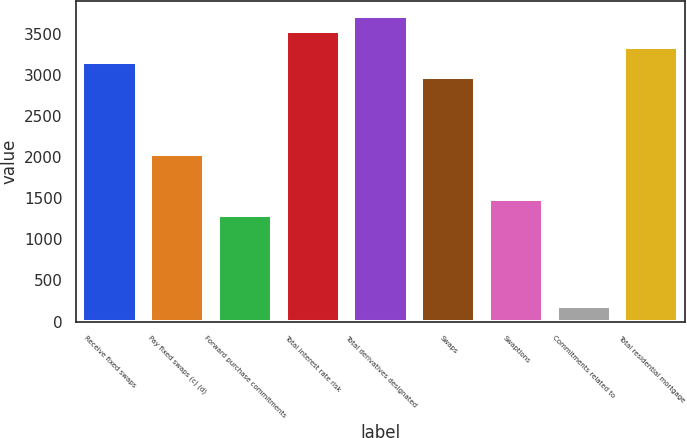Convert chart. <chart><loc_0><loc_0><loc_500><loc_500><bar_chart><fcel>Receive fixed swaps<fcel>Pay fixed swaps (c) (d)<fcel>Forward purchase commitments<fcel>Total interest rate risk<fcel>Total derivatives designated<fcel>Swaps<fcel>Swaptions<fcel>Commitments related to<fcel>Total residential mortgage<nl><fcel>3156.2<fcel>2042.6<fcel>1300.2<fcel>3527.4<fcel>3713<fcel>2970.6<fcel>1485.8<fcel>186.6<fcel>3341.8<nl></chart> 